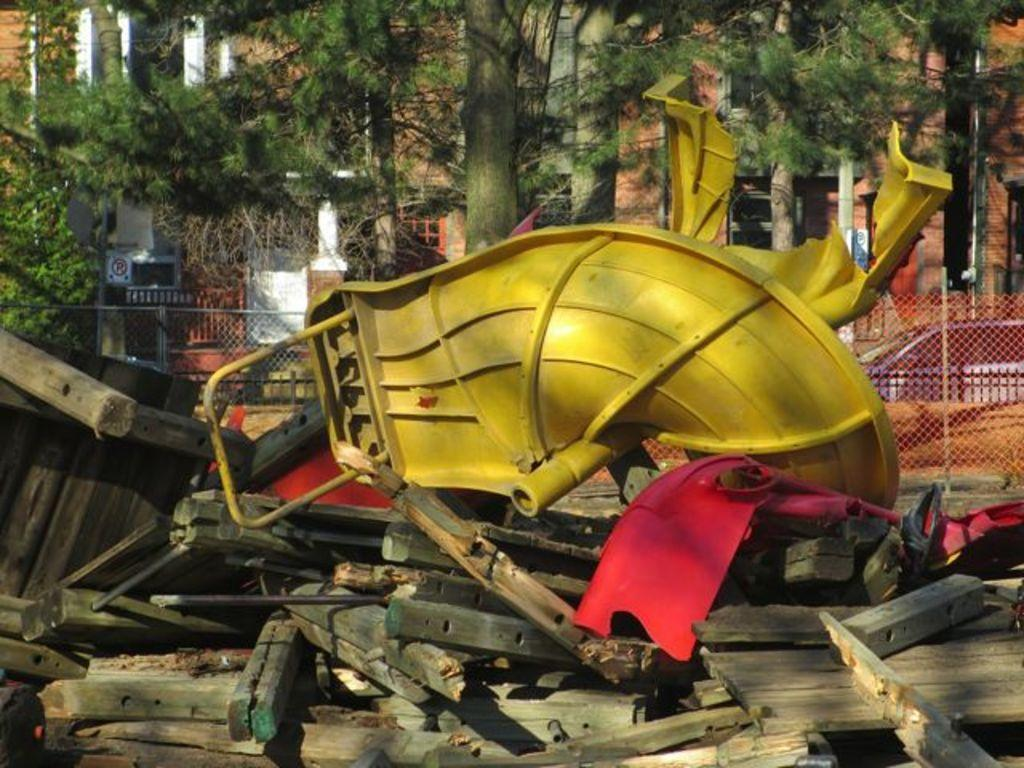What is the main subject of the image? The main subject of the image is a scrap. What can be seen in the background of the image? There are trees in front of a building in the image. What is located on the right side of the image? There is a mesh on the right side of the image. How many dinosaurs are visible in the image? There are no dinosaurs present in the image. What type of can is shown next to the scrap in the image? There is no can present in the image. 